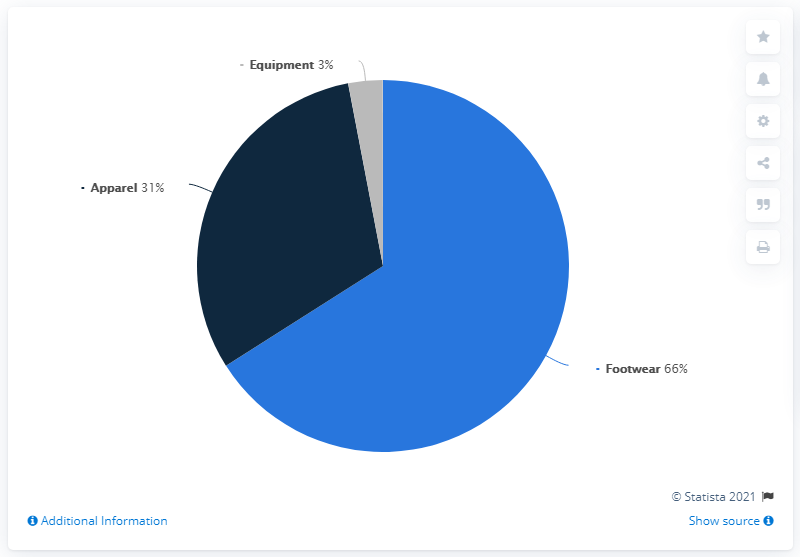Identify some key points in this picture. The revenue share of apparel and equipment combined is not greater than that of footwear alone, according to the data provided. The smallest color segment is gray. 